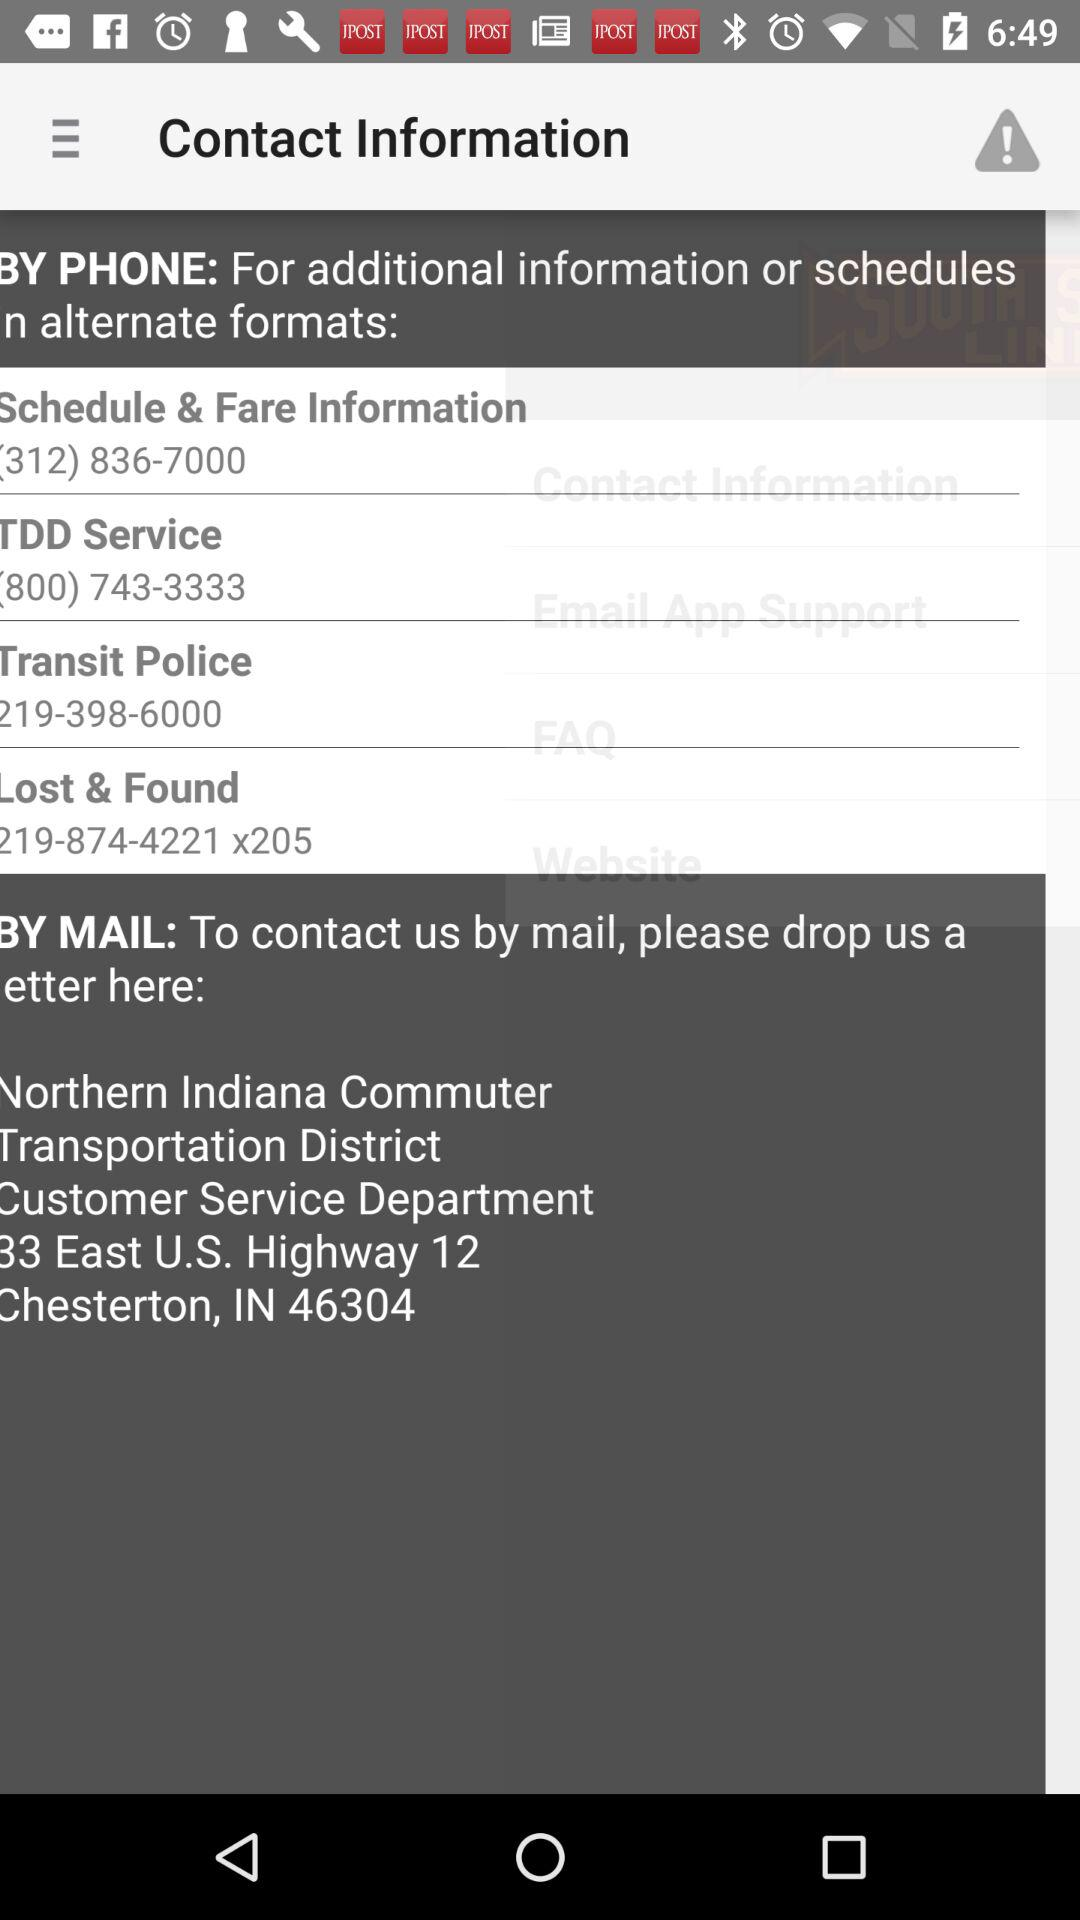What is the address to drop off a letter? The address is "Northern Indiana Commuter Transportation District Customer Service Department B3 East U.S. Highway 12, Chesterton, IN 46304". 